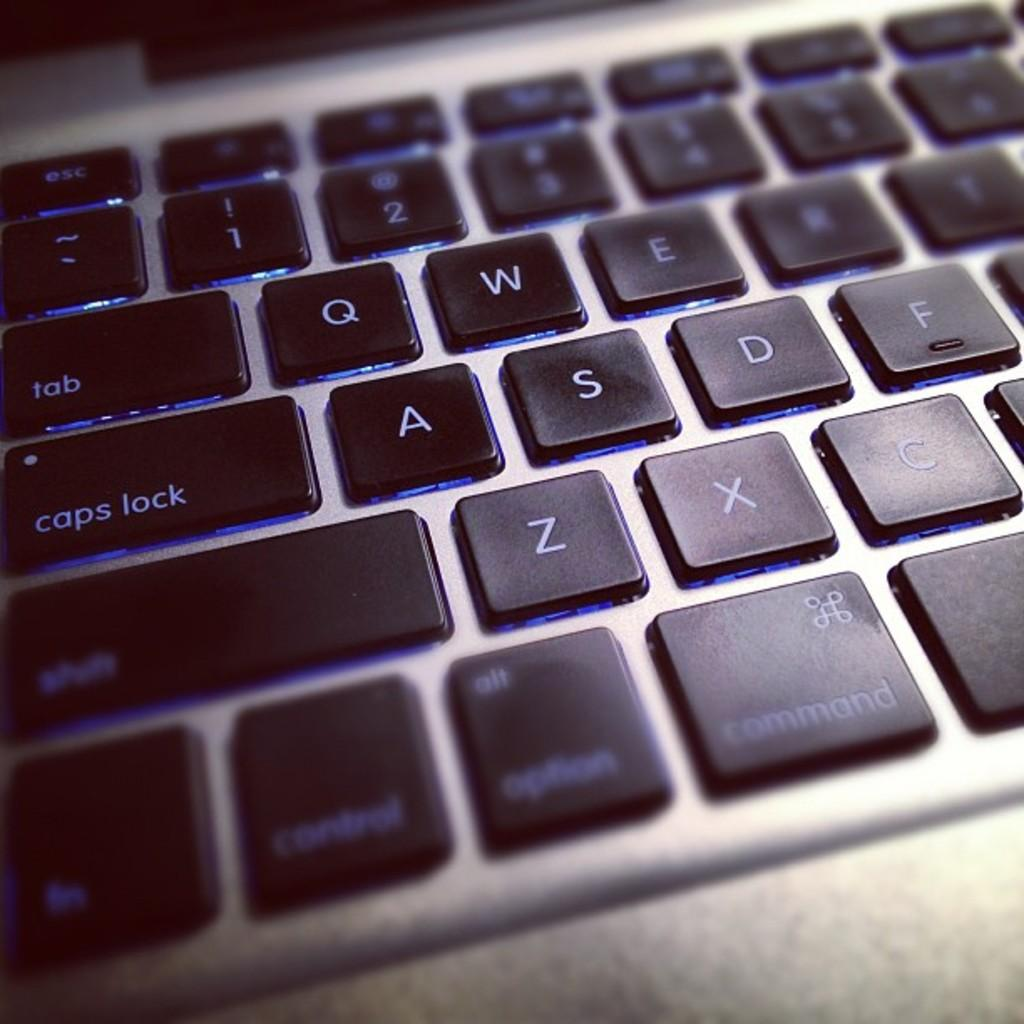<image>
Give a short and clear explanation of the subsequent image. A laptop keyboard with blue keys that say tab, caps lock, shift, and more. 